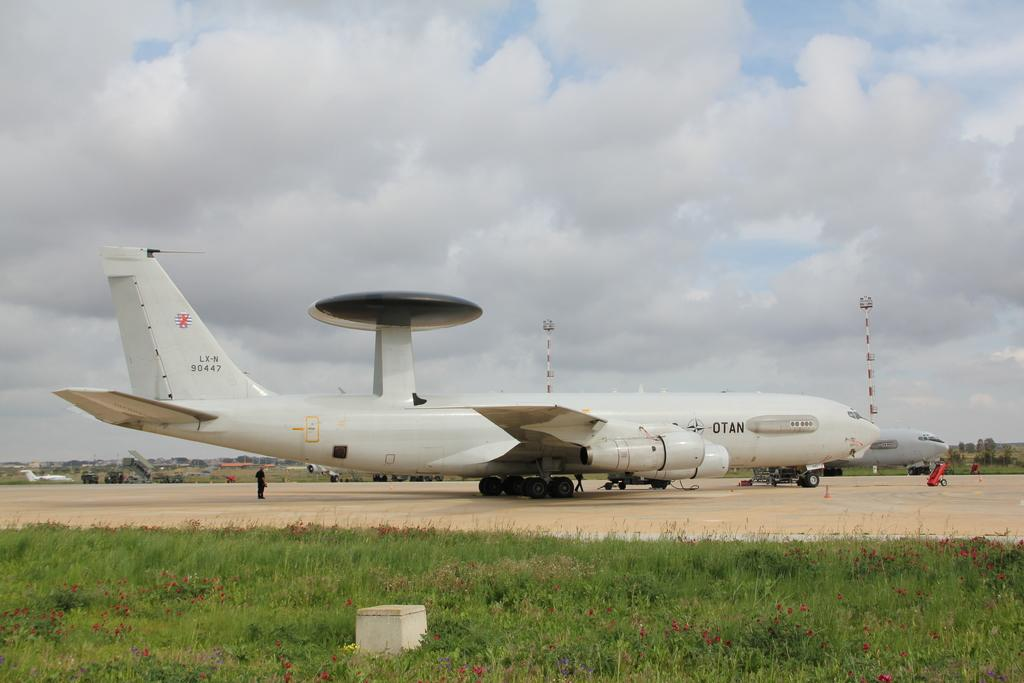What is the main subject of the image? The main subject of the image is aeroplanes on the ground. What type of terrain is visible at the bottom of the image? There is a grassy land at the bottom of the image. What can be seen in the sky in the image? The sky is cloudy and visible at the top of the image. How many crates are stacked next to the aeroplanes in the image? There are no crates present in the image. What type of ring can be seen on the aeroplane's wing in the image? There is no ring present on the aeroplanes' wings in the image. 